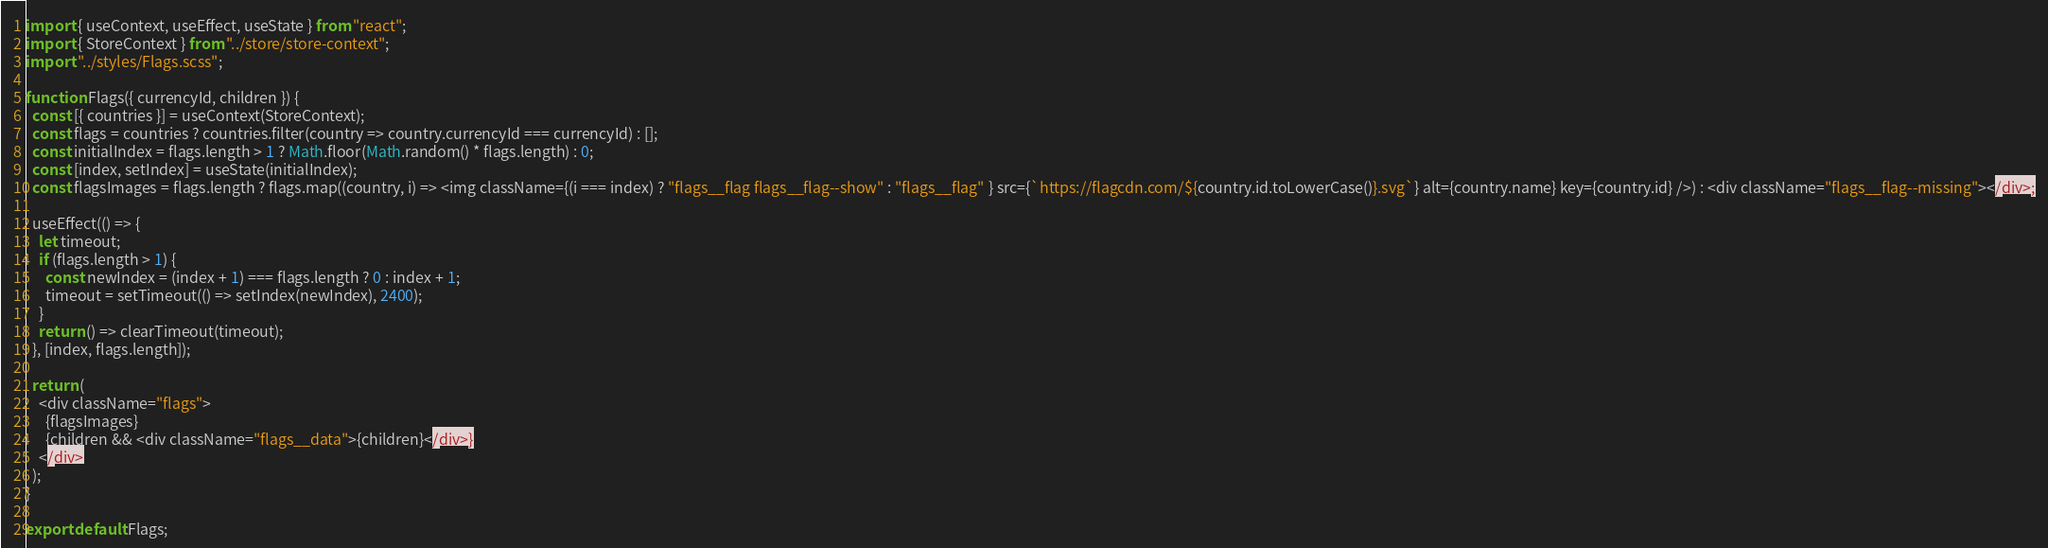<code> <loc_0><loc_0><loc_500><loc_500><_JavaScript_>import { useContext, useEffect, useState } from "react";
import { StoreContext } from "../store/store-context";
import "../styles/Flags.scss";

function Flags({ currencyId, children }) {
  const [{ countries }] = useContext(StoreContext);
  const flags = countries ? countries.filter(country => country.currencyId === currencyId) : [];
  const initialIndex = flags.length > 1 ? Math.floor(Math.random() * flags.length) : 0;
  const [index, setIndex] = useState(initialIndex);
  const flagsImages = flags.length ? flags.map((country, i) => <img className={(i === index) ? "flags__flag flags__flag--show" : "flags__flag" } src={`https://flagcdn.com/${country.id.toLowerCase()}.svg`} alt={country.name} key={country.id} />) : <div className="flags__flag--missing"></div>;

  useEffect(() => {
    let timeout;
    if (flags.length > 1) {
      const newIndex = (index + 1) === flags.length ? 0 : index + 1;
      timeout = setTimeout(() => setIndex(newIndex), 2400);
    }
    return () => clearTimeout(timeout);
  }, [index, flags.length]);

  return (
    <div className="flags">
      {flagsImages}
      {children && <div className="flags__data">{children}</div>}
    </div>
  );
}

export default Flags;</code> 